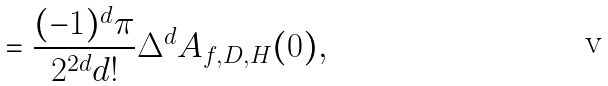<formula> <loc_0><loc_0><loc_500><loc_500>= \frac { ( - 1 ) ^ { d } \pi } { 2 ^ { 2 d } d ! } \Delta ^ { d } A _ { f , D , H } ( 0 ) ,</formula> 